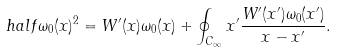<formula> <loc_0><loc_0><loc_500><loc_500>\ h a l f \omega _ { 0 } ( x ) ^ { 2 } = W ^ { \prime } ( x ) \omega _ { 0 } ( x ) + \oint _ { C _ { \infty } } { x ^ { \prime } } \frac { W ^ { \prime } ( x ^ { \prime } ) \omega _ { 0 } ( x ^ { \prime } ) } { x - x ^ { \prime } } .</formula> 